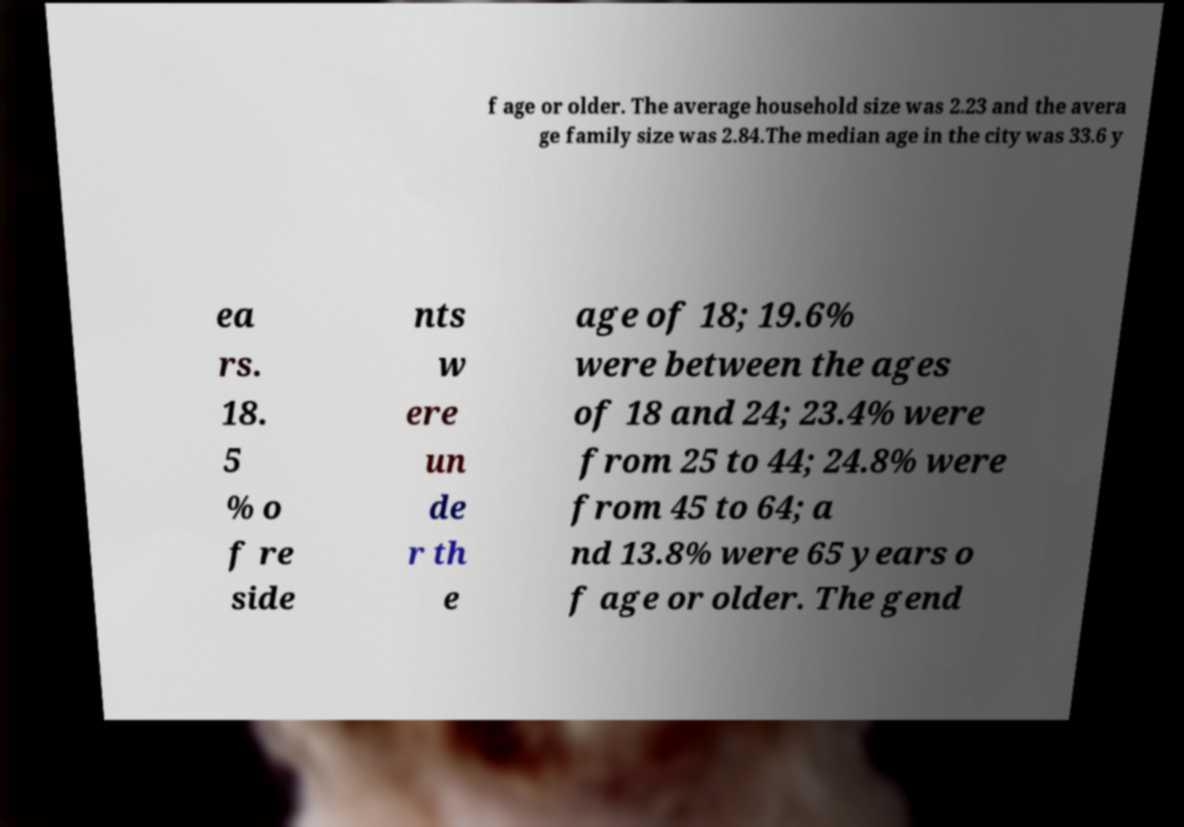For documentation purposes, I need the text within this image transcribed. Could you provide that? f age or older. The average household size was 2.23 and the avera ge family size was 2.84.The median age in the city was 33.6 y ea rs. 18. 5 % o f re side nts w ere un de r th e age of 18; 19.6% were between the ages of 18 and 24; 23.4% were from 25 to 44; 24.8% were from 45 to 64; a nd 13.8% were 65 years o f age or older. The gend 